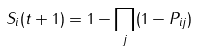<formula> <loc_0><loc_0><loc_500><loc_500>S _ { i } ( t + 1 ) = 1 - \prod _ { j } ( 1 - P _ { i j } )</formula> 